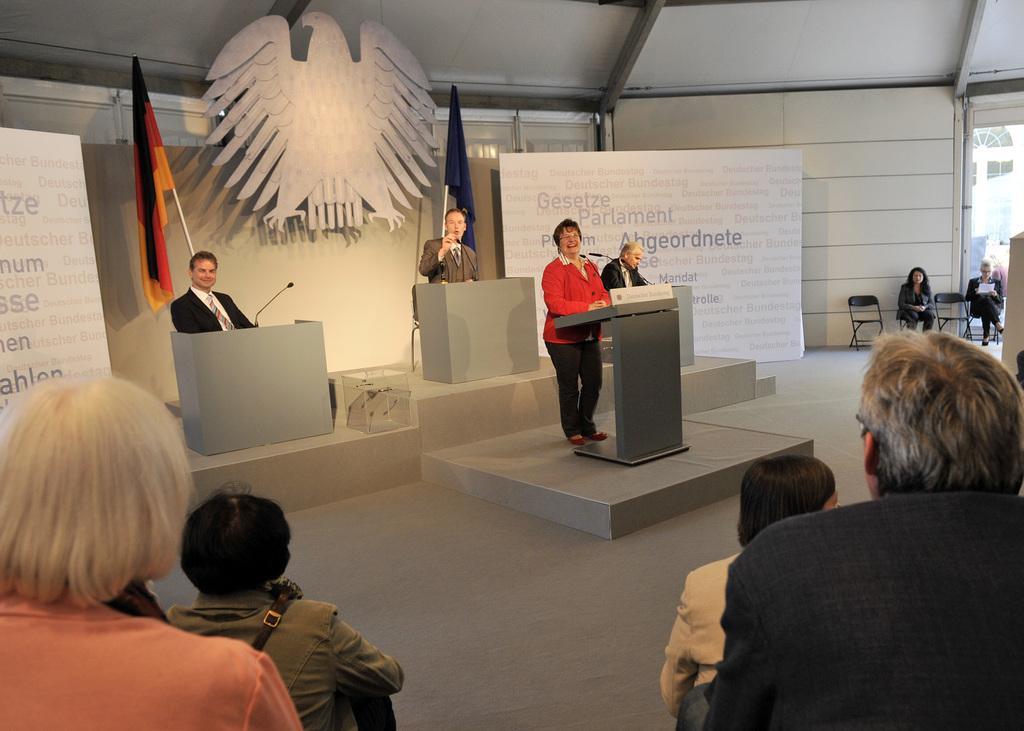Can you describe this image briefly? In this image I can see group of people, in front I can see four persons. I can see the person standing in front of the podium and I can also see few microphones. Background I can see a flag in black, orange and yellow color and I can see a glass wall and I can see the wall in white color. 